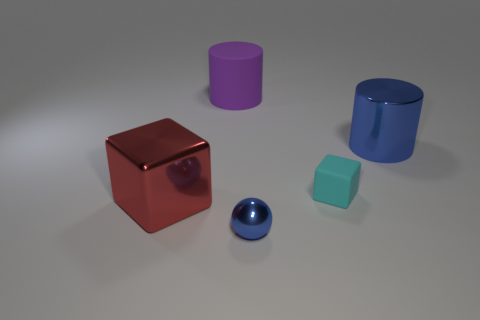Does the big rubber object have the same color as the matte thing that is on the right side of the small sphere?
Ensure brevity in your answer.  No. What is the shape of the metal object that is behind the tiny blue shiny ball and to the right of the large purple matte cylinder?
Your answer should be very brief. Cylinder. What is the large cylinder that is on the left side of the shiny thing that is right of the metal object in front of the big block made of?
Keep it short and to the point. Rubber. Are there more cyan cubes that are in front of the large red block than big purple rubber things on the right side of the tiny blue ball?
Your response must be concise. No. How many other small cubes are made of the same material as the small cyan block?
Make the answer very short. 0. There is a big shiny object in front of the tiny cyan block; is it the same shape as the blue object that is on the right side of the tiny rubber block?
Offer a terse response. No. There is a large thing to the right of the blue metal ball; what color is it?
Make the answer very short. Blue. Are there any other tiny metallic objects of the same shape as the small blue metallic object?
Your answer should be compact. No. What is the material of the large purple cylinder?
Provide a short and direct response. Rubber. There is a shiny thing that is in front of the blue cylinder and to the right of the large red metallic thing; how big is it?
Your answer should be compact. Small. 